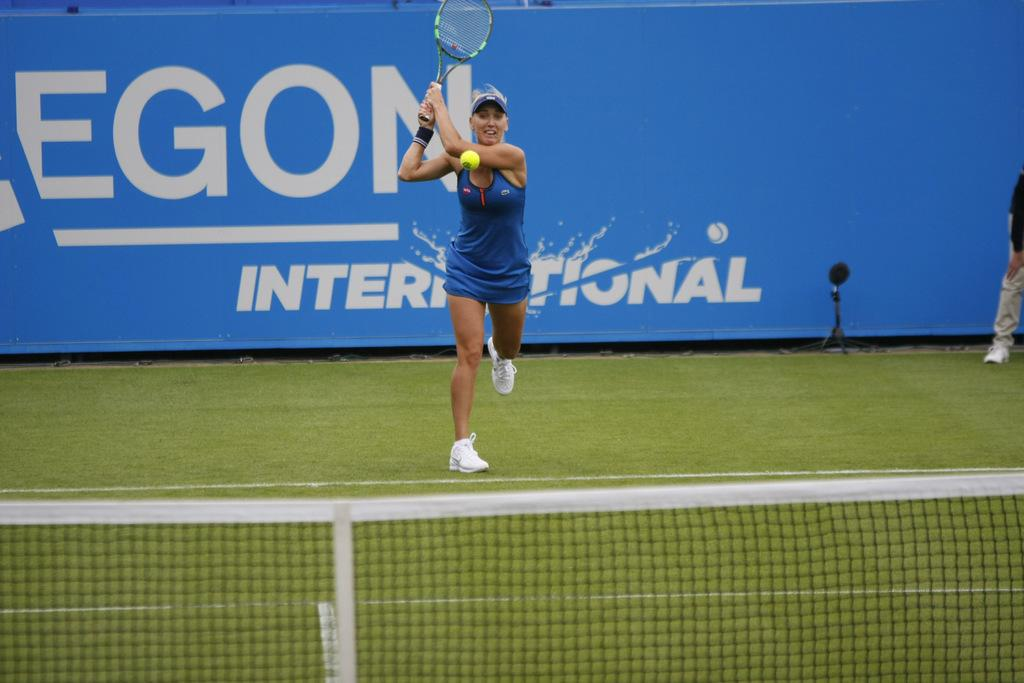Who is the main subject in the image? There is a woman in the image. What is the woman doing in the image? The woman is playing tennis. What equipment is the woman using to play tennis? The woman is using a tennis racket. Where is the woman playing tennis? The setting is a tennis court. Who else is present in the image? There is an umpire watching the woman play tennis. What type of boats can be seen in the image? There are no boats present in the image; it features a woman playing tennis on a tennis court. How many acts are performed by the woman in the image? The image does not depict any acts being performed by the woman; she is simply playing tennis. 